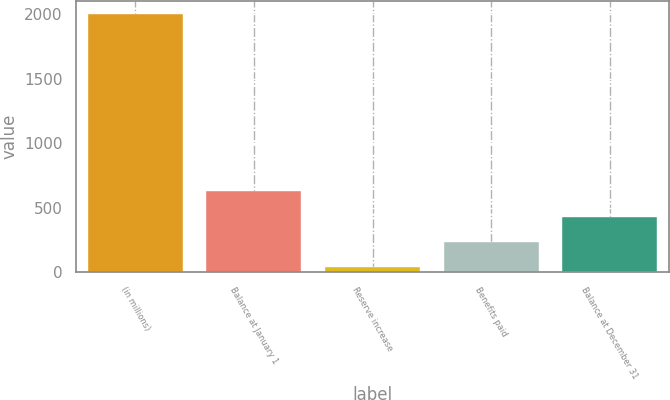<chart> <loc_0><loc_0><loc_500><loc_500><bar_chart><fcel>(in millions)<fcel>Balance at January 1<fcel>Reserve increase<fcel>Benefits paid<fcel>Balance at December 31<nl><fcel>2006<fcel>626.3<fcel>35<fcel>232.1<fcel>429.2<nl></chart> 